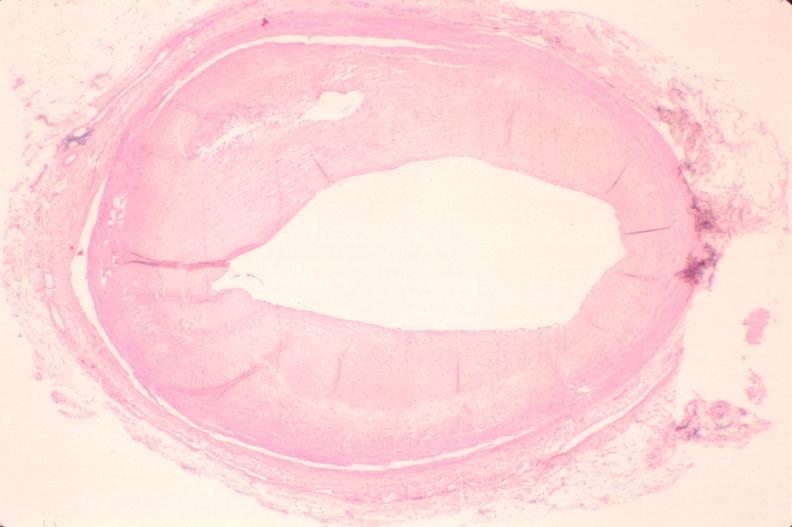s peritoneum present?
Answer the question using a single word or phrase. No 